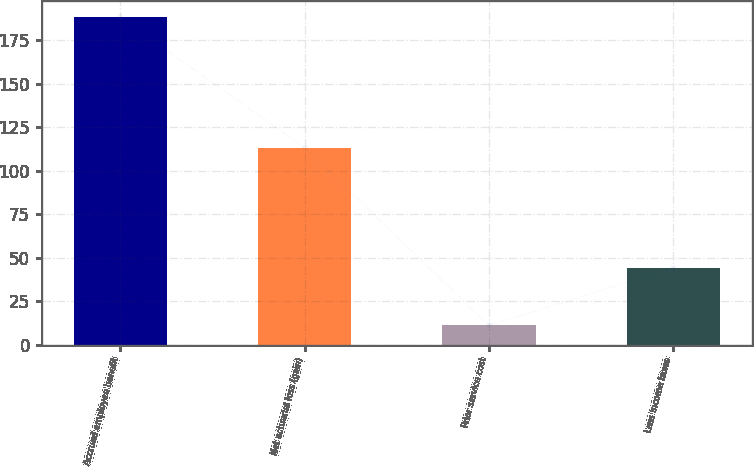<chart> <loc_0><loc_0><loc_500><loc_500><bar_chart><fcel>Accrued employee benefit<fcel>Net actuarial loss (gain)<fcel>Prior service cost<fcel>Less Income taxes<nl><fcel>188<fcel>113<fcel>11<fcel>44<nl></chart> 